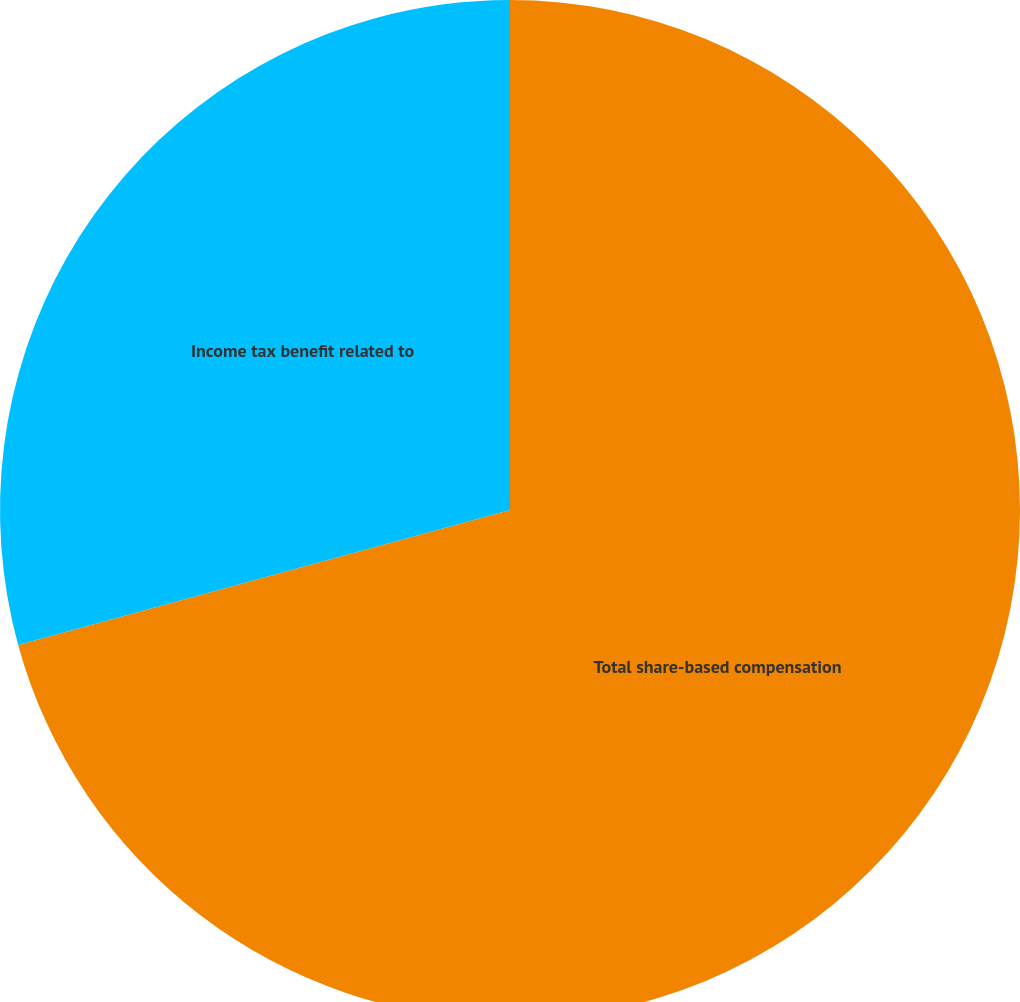Convert chart. <chart><loc_0><loc_0><loc_500><loc_500><pie_chart><fcel>Total share-based compensation<fcel>Income tax benefit related to<nl><fcel>70.74%<fcel>29.26%<nl></chart> 